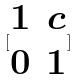Convert formula to latex. <formula><loc_0><loc_0><loc_500><loc_500>[ \begin{matrix} 1 & c \\ 0 & 1 \end{matrix} ]</formula> 